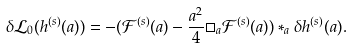Convert formula to latex. <formula><loc_0><loc_0><loc_500><loc_500>\delta \mathcal { L } _ { 0 } ( h ^ { ( s ) } ( a ) ) = - ( \mathcal { F } ^ { ( s ) } ( a ) - \frac { a ^ { 2 } } { 4 } \Box _ { a } \mathcal { F } ^ { ( s ) } ( a ) ) * _ { a } \delta h ^ { ( s ) } ( a ) .</formula> 